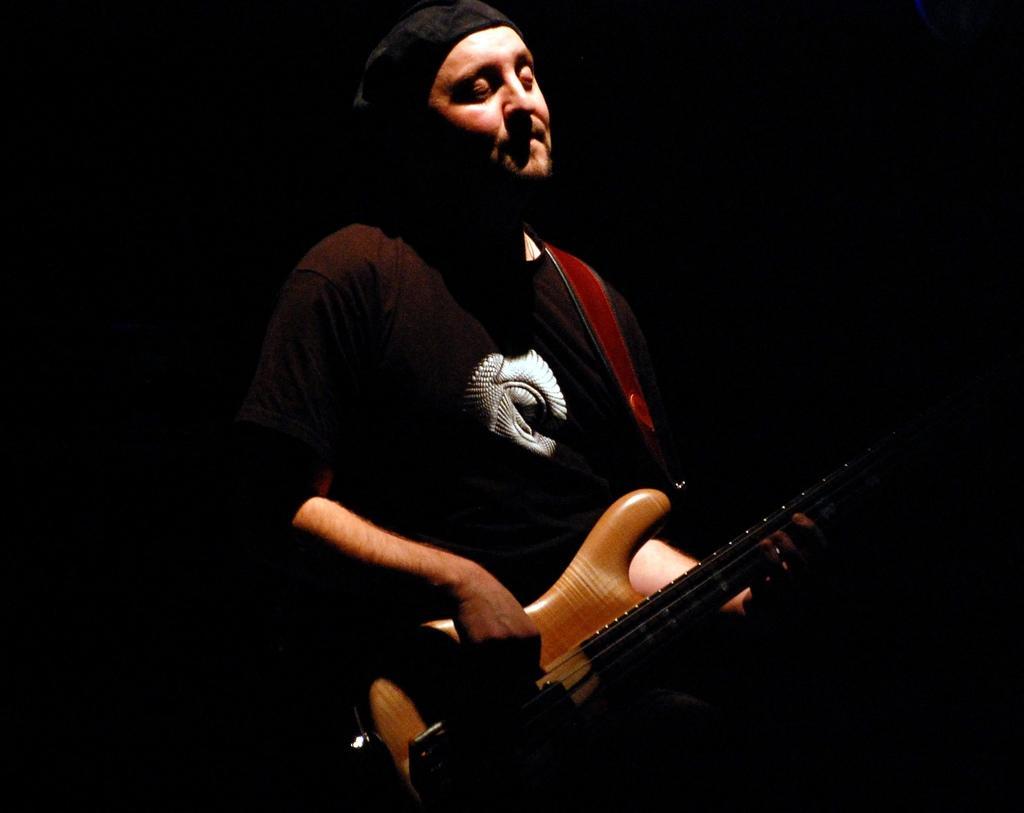How would you summarize this image in a sentence or two? In the middle of the image, there is a person in a t-shirt, standing, holding a guitar and playing. And the background is dark in color. 